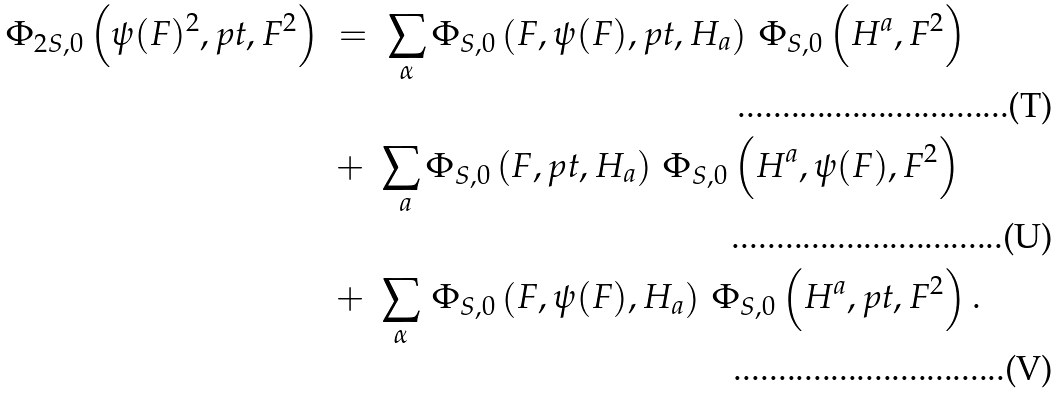Convert formula to latex. <formula><loc_0><loc_0><loc_500><loc_500>\Phi _ { 2 S , 0 } \left ( \psi ( F ) ^ { 2 } , p t , F ^ { 2 } \right ) \ & = \ \sum _ { \alpha } \Phi _ { S , 0 } \left ( F , \psi ( F ) , p t , H _ { a } \right ) \, \Phi _ { S , 0 } \left ( H ^ { a } , F ^ { 2 } \right ) \\ & + \ \sum _ { \ a } \Phi _ { S , 0 } \left ( F , p t , H _ { a } \right ) \, \Phi _ { S , 0 } \left ( H ^ { a } , \psi ( F ) , F ^ { 2 } \right ) \\ & + \ \sum _ { \alpha } \, \Phi _ { S , 0 } \left ( F , \psi ( F ) , H _ { a } \right ) \, \Phi _ { S , 0 } \left ( H ^ { a } , p t , F ^ { 2 } \right ) .</formula> 